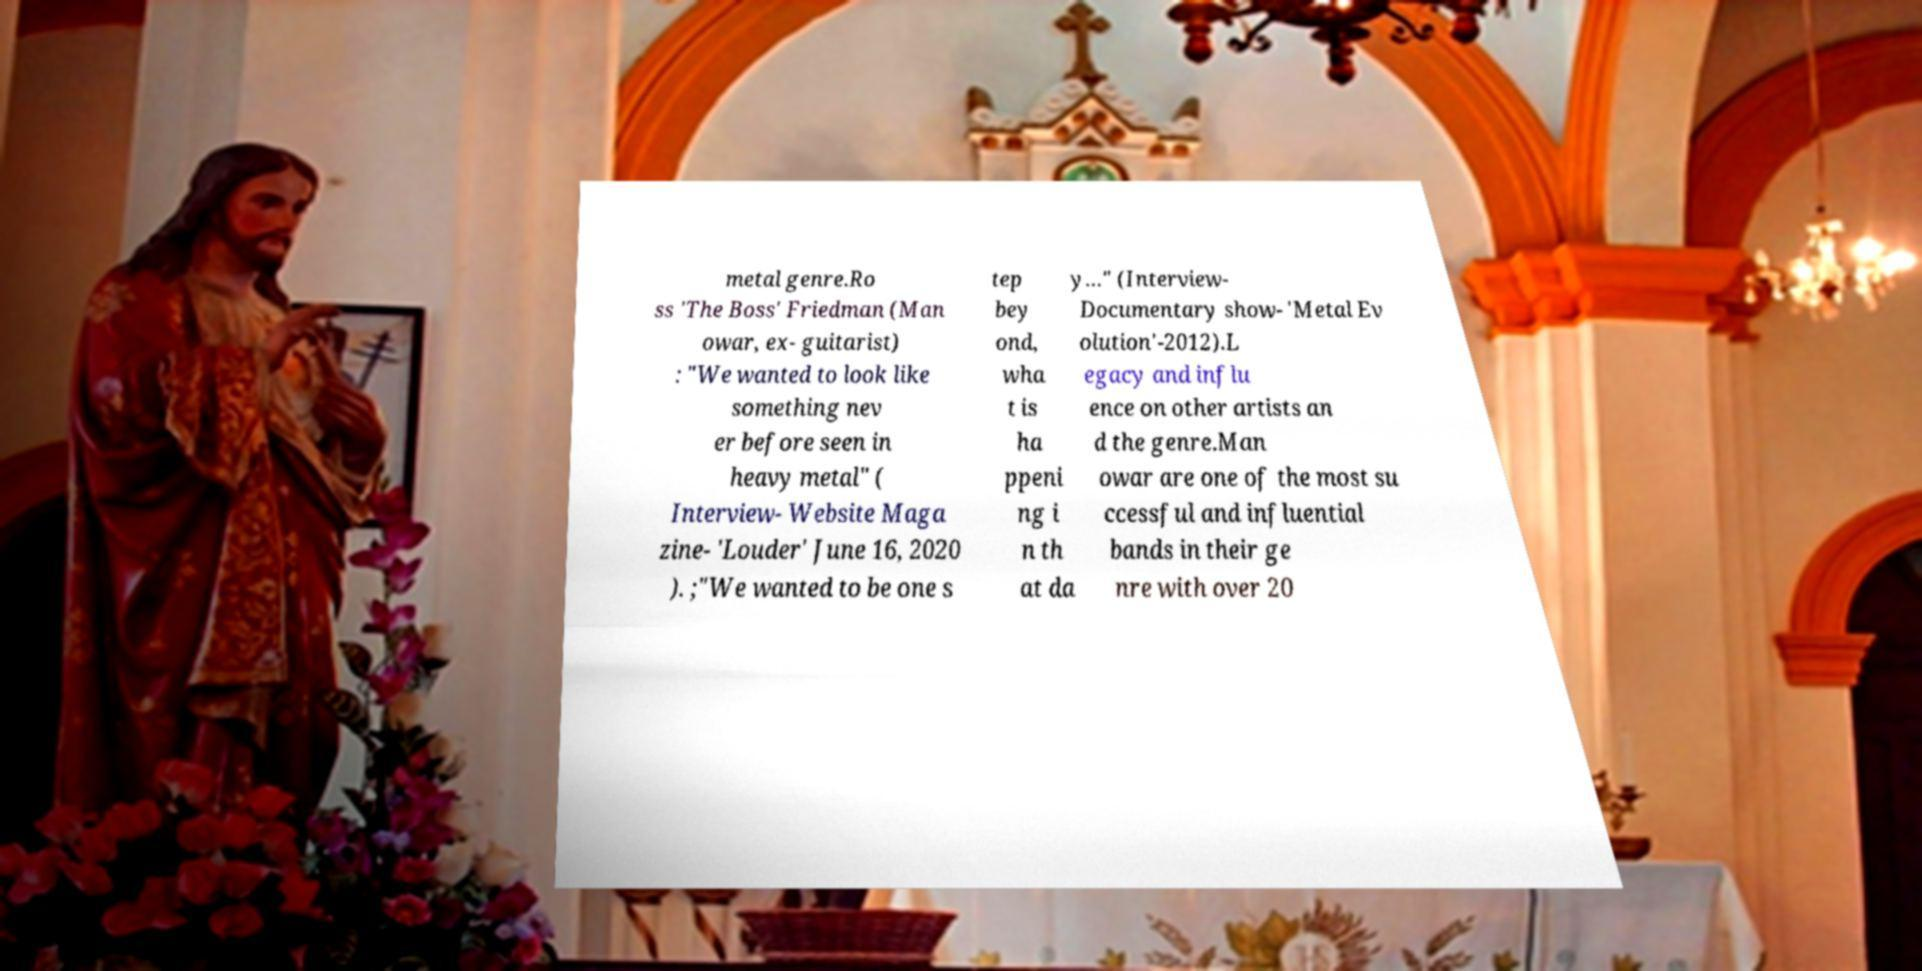Can you accurately transcribe the text from the provided image for me? metal genre.Ro ss 'The Boss' Friedman (Man owar, ex- guitarist) : "We wanted to look like something nev er before seen in heavy metal" ( Interview- Website Maga zine- 'Louder' June 16, 2020 ). ;"We wanted to be one s tep bey ond, wha t is ha ppeni ng i n th at da y…" (Interview- Documentary show- 'Metal Ev olution'-2012).L egacy and influ ence on other artists an d the genre.Man owar are one of the most su ccessful and influential bands in their ge nre with over 20 